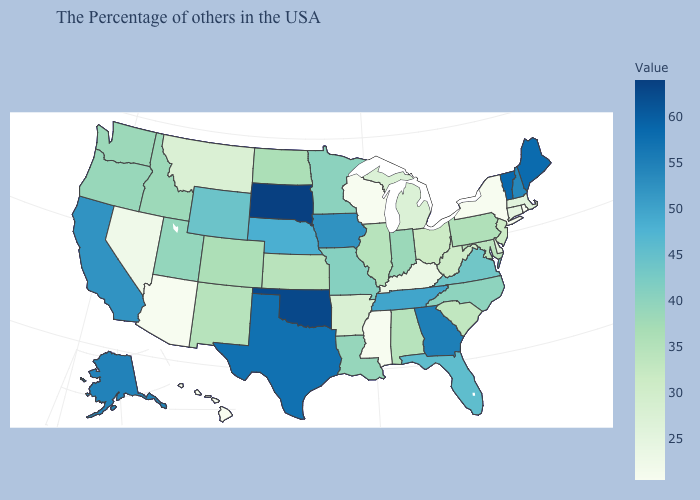Which states have the lowest value in the USA?
Quick response, please. Rhode Island, New York, Wisconsin, Mississippi, Arizona, Hawaii. Does Alaska have the highest value in the West?
Answer briefly. Yes. Among the states that border Oklahoma , does Texas have the highest value?
Keep it brief. Yes. 